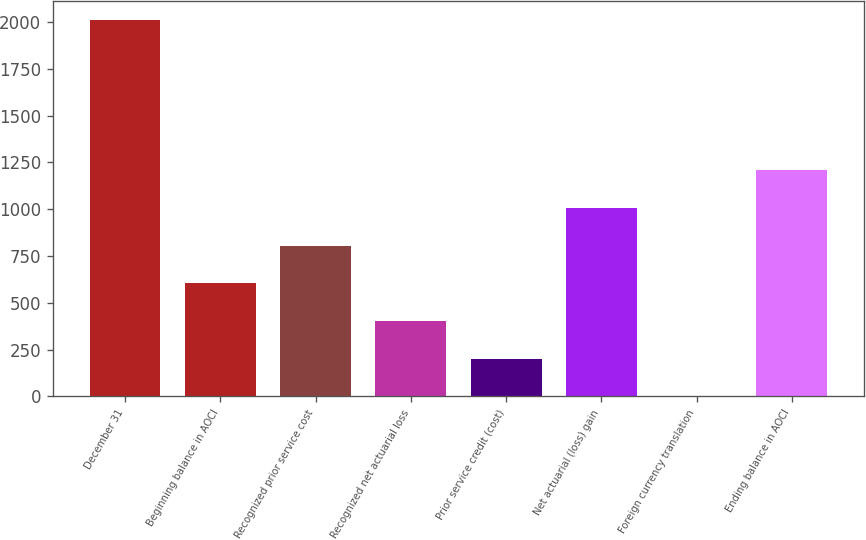Convert chart. <chart><loc_0><loc_0><loc_500><loc_500><bar_chart><fcel>December 31<fcel>Beginning balance in AOCI<fcel>Recognized prior service cost<fcel>Recognized net actuarial loss<fcel>Prior service credit (cost)<fcel>Net actuarial (loss) gain<fcel>Foreign currency translation<fcel>Ending balance in AOCI<nl><fcel>2012<fcel>604.3<fcel>805.4<fcel>403.2<fcel>202.1<fcel>1006.5<fcel>1<fcel>1207.6<nl></chart> 